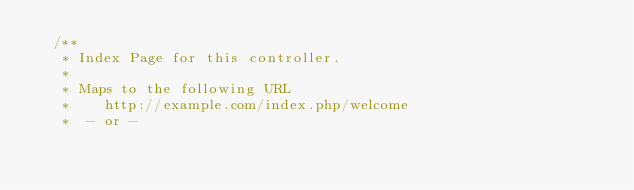<code> <loc_0><loc_0><loc_500><loc_500><_PHP_>	/**
	 * Index Page for this controller.
	 *
	 * Maps to the following URL
	 * 		http://example.com/index.php/welcome
	 *	- or -</code> 